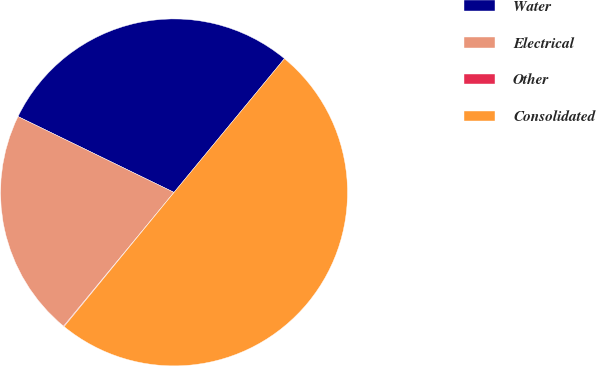<chart> <loc_0><loc_0><loc_500><loc_500><pie_chart><fcel>Water<fcel>Electrical<fcel>Other<fcel>Consolidated<nl><fcel>28.78%<fcel>21.22%<fcel>0.06%<fcel>49.94%<nl></chart> 